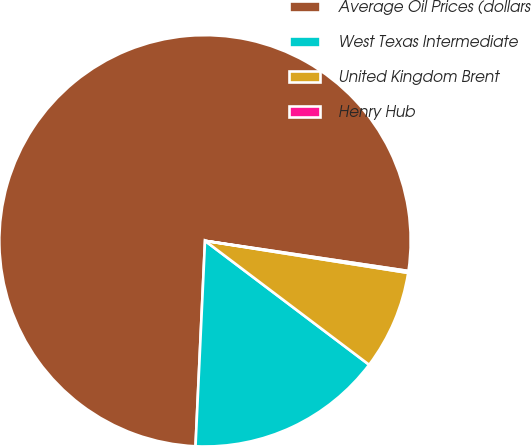Convert chart to OTSL. <chart><loc_0><loc_0><loc_500><loc_500><pie_chart><fcel>Average Oil Prices (dollars<fcel>West Texas Intermediate<fcel>United Kingdom Brent<fcel>Henry Hub<nl><fcel>76.6%<fcel>15.44%<fcel>7.8%<fcel>0.15%<nl></chart> 